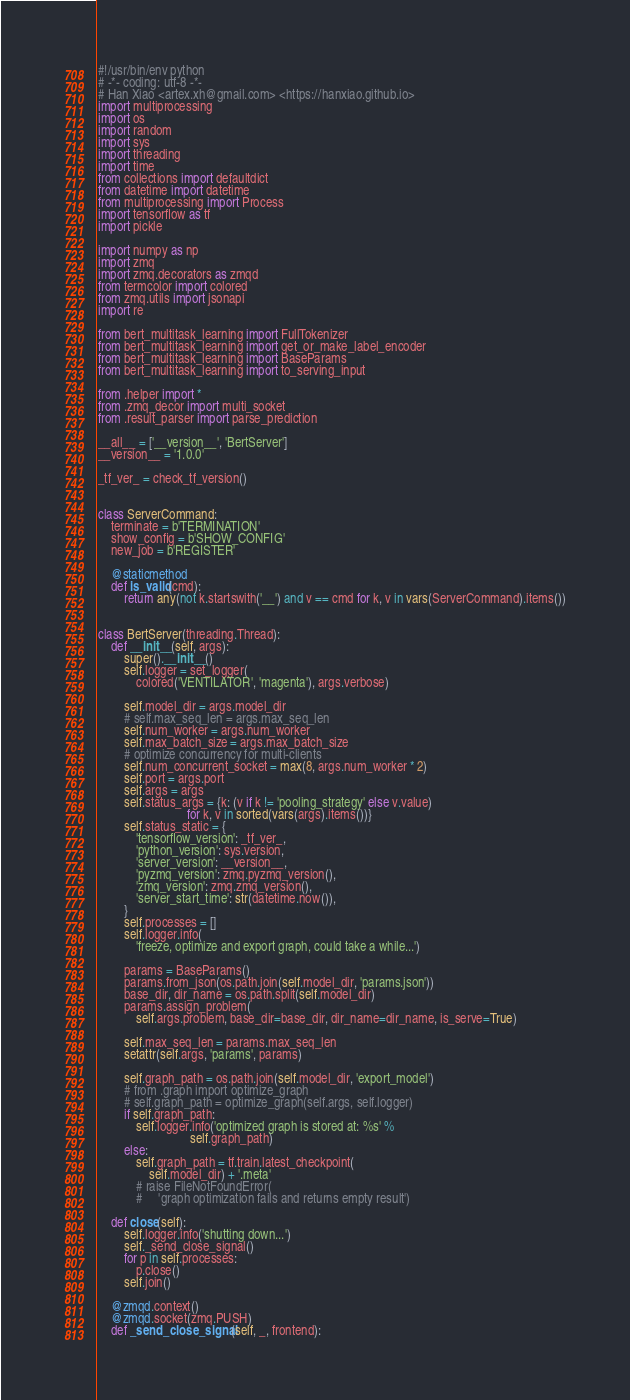Convert code to text. <code><loc_0><loc_0><loc_500><loc_500><_Python_>#!/usr/bin/env python
# -*- coding: utf-8 -*-
# Han Xiao <artex.xh@gmail.com> <https://hanxiao.github.io>
import multiprocessing
import os
import random
import sys
import threading
import time
from collections import defaultdict
from datetime import datetime
from multiprocessing import Process
import tensorflow as tf
import pickle

import numpy as np
import zmq
import zmq.decorators as zmqd
from termcolor import colored
from zmq.utils import jsonapi
import re

from bert_multitask_learning import FullTokenizer
from bert_multitask_learning import get_or_make_label_encoder
from bert_multitask_learning import BaseParams
from bert_multitask_learning import to_serving_input

from .helper import *
from .zmq_decor import multi_socket
from .result_parser import parse_prediction

__all__ = ['__version__', 'BertServer']
__version__ = '1.0.0'

_tf_ver_ = check_tf_version()


class ServerCommand:
    terminate = b'TERMINATION'
    show_config = b'SHOW_CONFIG'
    new_job = b'REGISTER'

    @staticmethod
    def is_valid(cmd):
        return any(not k.startswith('__') and v == cmd for k, v in vars(ServerCommand).items())


class BertServer(threading.Thread):
    def __init__(self, args):
        super().__init__()
        self.logger = set_logger(
            colored('VENTILATOR', 'magenta'), args.verbose)

        self.model_dir = args.model_dir
        # self.max_seq_len = args.max_seq_len
        self.num_worker = args.num_worker
        self.max_batch_size = args.max_batch_size
        # optimize concurrency for multi-clients
        self.num_concurrent_socket = max(8, args.num_worker * 2)
        self.port = args.port
        self.args = args
        self.status_args = {k: (v if k != 'pooling_strategy' else v.value)
                            for k, v in sorted(vars(args).items())}
        self.status_static = {
            'tensorflow_version': _tf_ver_,
            'python_version': sys.version,
            'server_version': __version__,
            'pyzmq_version': zmq.pyzmq_version(),
            'zmq_version': zmq.zmq_version(),
            'server_start_time': str(datetime.now()),
        }
        self.processes = []
        self.logger.info(
            'freeze, optimize and export graph, could take a while...')

        params = BaseParams()
        params.from_json(os.path.join(self.model_dir, 'params.json'))
        base_dir, dir_name = os.path.split(self.model_dir)
        params.assign_problem(
            self.args.problem, base_dir=base_dir, dir_name=dir_name, is_serve=True)

        self.max_seq_len = params.max_seq_len
        setattr(self.args, 'params', params)

        self.graph_path = os.path.join(self.model_dir, 'export_model')
        # from .graph import optimize_graph
        # self.graph_path = optimize_graph(self.args, self.logger)
        if self.graph_path:
            self.logger.info('optimized graph is stored at: %s' %
                             self.graph_path)
        else:
            self.graph_path = tf.train.latest_checkpoint(
                self.model_dir) + '.meta'
            # raise FileNotFoundError(
            #     'graph optimization fails and returns empty result')

    def close(self):
        self.logger.info('shutting down...')
        self._send_close_signal()
        for p in self.processes:
            p.close()
        self.join()

    @zmqd.context()
    @zmqd.socket(zmq.PUSH)
    def _send_close_signal(self, _, frontend):</code> 